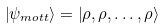Convert formula to latex. <formula><loc_0><loc_0><loc_500><loc_500>\left | \psi _ { m o t t } \right \rangle = \left | \rho , \rho , \dots , \rho \right \rangle</formula> 